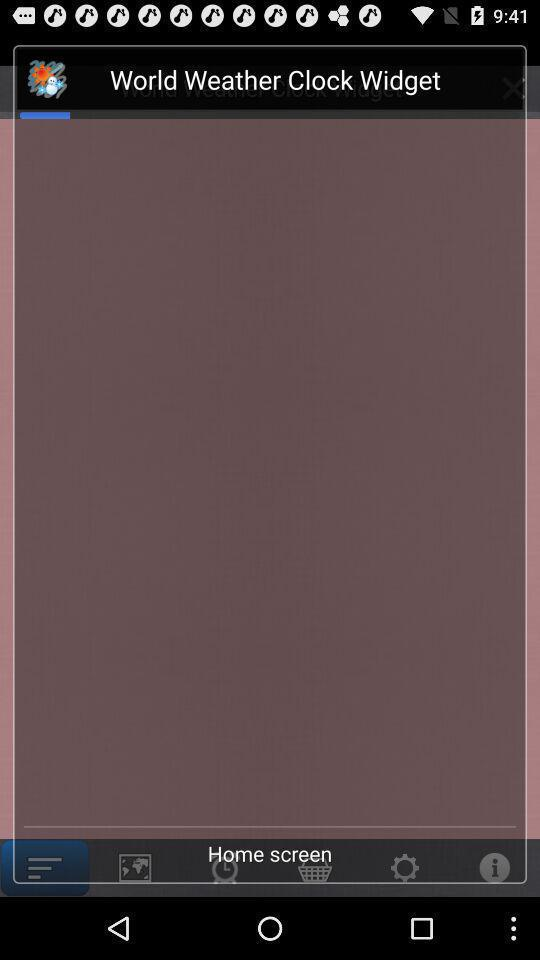What is the name of the application? The name of the application is "World Weather Clock Widget". 